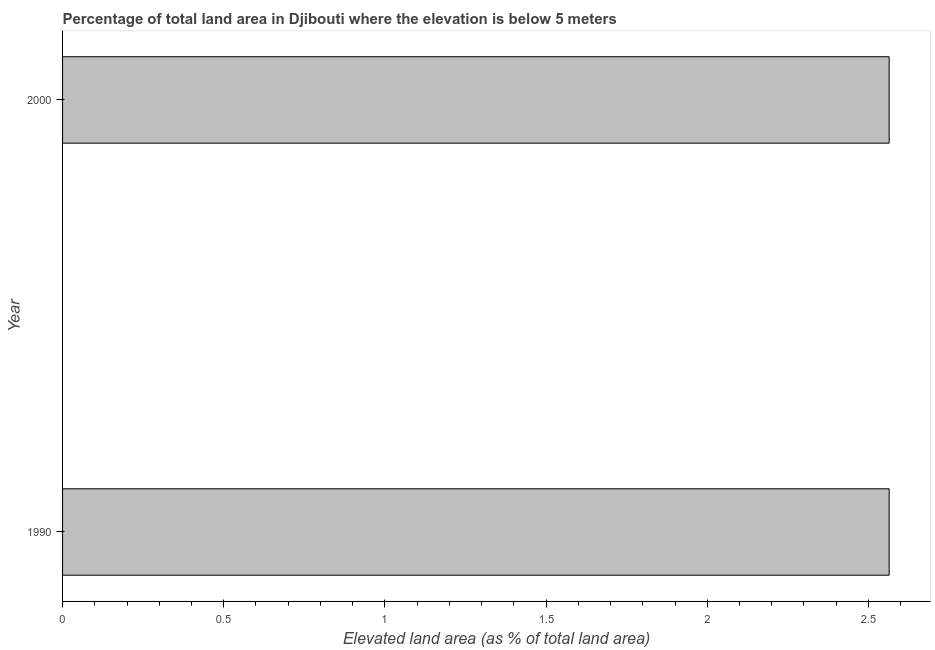Does the graph contain any zero values?
Offer a very short reply. No. Does the graph contain grids?
Your answer should be compact. No. What is the title of the graph?
Your response must be concise. Percentage of total land area in Djibouti where the elevation is below 5 meters. What is the label or title of the X-axis?
Your response must be concise. Elevated land area (as % of total land area). What is the label or title of the Y-axis?
Offer a terse response. Year. What is the total elevated land area in 1990?
Offer a very short reply. 2.56. Across all years, what is the maximum total elevated land area?
Provide a succinct answer. 2.56. Across all years, what is the minimum total elevated land area?
Keep it short and to the point. 2.56. In which year was the total elevated land area maximum?
Give a very brief answer. 1990. What is the sum of the total elevated land area?
Give a very brief answer. 5.13. What is the difference between the total elevated land area in 1990 and 2000?
Your answer should be very brief. 0. What is the average total elevated land area per year?
Offer a terse response. 2.56. What is the median total elevated land area?
Ensure brevity in your answer.  2.56. Do a majority of the years between 1990 and 2000 (inclusive) have total elevated land area greater than 1.9 %?
Offer a terse response. Yes. What is the ratio of the total elevated land area in 1990 to that in 2000?
Provide a short and direct response. 1. Is the total elevated land area in 1990 less than that in 2000?
Keep it short and to the point. No. In how many years, is the total elevated land area greater than the average total elevated land area taken over all years?
Make the answer very short. 0. How many years are there in the graph?
Provide a short and direct response. 2. Are the values on the major ticks of X-axis written in scientific E-notation?
Offer a very short reply. No. What is the Elevated land area (as % of total land area) of 1990?
Your response must be concise. 2.56. What is the Elevated land area (as % of total land area) of 2000?
Your response must be concise. 2.56. What is the difference between the Elevated land area (as % of total land area) in 1990 and 2000?
Offer a very short reply. 0. 